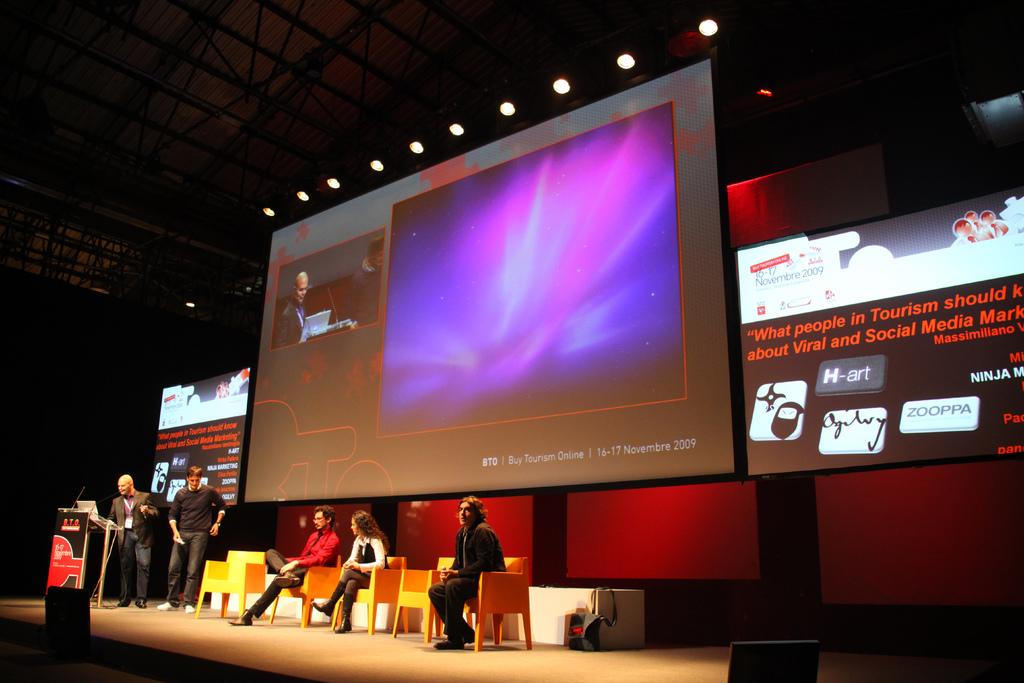What is the title of the talk?
Make the answer very short. What people in tourism should know about viral and social media marketing. What does the text in red say?
Ensure brevity in your answer.  What people in tourism should know about viral and social media marketing. 